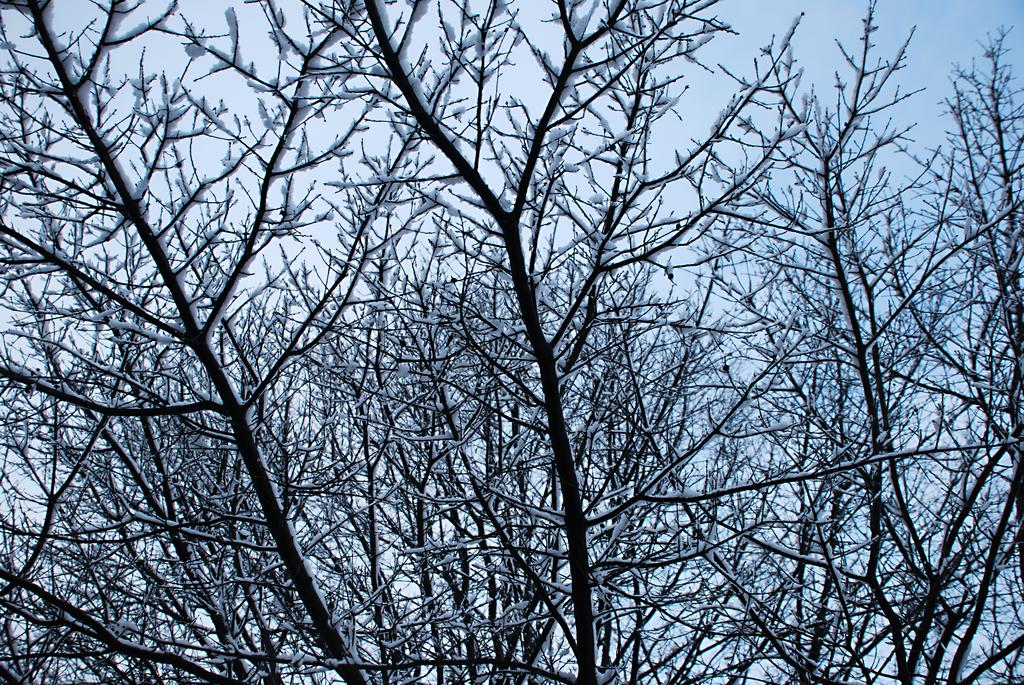What type of weather condition is depicted in the image? The image shows snow on dry branches, indicating a cold and wintry scene. Can you describe the branches in the image? The branches are dry, which suggests that they are not currently in use by leaves or other vegetation. Where is the group of people gathered on the island in the image? There is no group of people or island present in the image; it only shows snow on dry branches. 